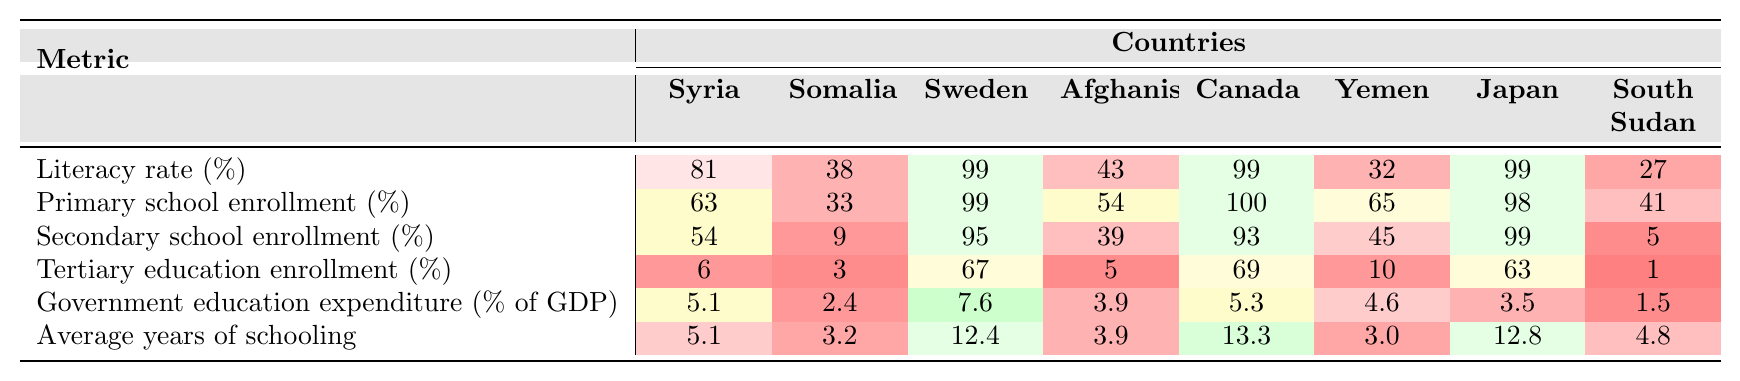What is the literacy rate in Syria? The table shows that the literacy rate in Syria is listed under the Literacy rate row and Syria column, which indicates a value of 81%
Answer: 81% What is the average years of schooling in Japan? The average years of schooling in Japan can be found under the Average years of schooling row and Japan column, showing a value of 12.8
Answer: 12.8 Which country has the highest primary school enrollment percentage? Looking at the Primary school enrollment row, Canada has the highest percentage at 100%, compared to the other listed countries
Answer: Canada Is the secondary school enrollment higher in Sweden or Canada? In the Secondary school enrollment row, Sweden has a value of 95, while Canada has a value of 93. Therefore, Sweden has the higher enrollment
Answer: Sweden What is the difference in tertiary education enrollment between Yemen and Somalia? Yemen's tertiary education enrollment is 10%, and Somalia's is 3%. The difference is 10 - 3 = 7%
Answer: 7% Which country has the lowest governmental education expenditure as a percentage of GDP? The Government education expenditure row indicates South Sudan has the lowest value at 1.5%
Answer: South Sudan Is the primary school enrollment in South Sudan higher than that of Afghanistan? The primary school enrollment in South Sudan is 41%, while Afghanistan's is 54%. Since 41% is less than 54%, the statement is false
Answer: No What is the average literacy rate of conflict-affected countries (Syria, Somalia, Afghanistan, Yemen, South Sudan)? Calculating the average involves summing the literacy rates: (81 + 63 + 6 + 32 + 27) = 209. Then, divide by 5, which gives 209/5 = 41.8
Answer: 41.8 Which country has a literacy rate higher than 90%? Reviewing the Literacy rate row, Sweden, Canada, and Japan all have literacy rates at or above 99%, meaning they fit this criterion
Answer: Sweden, Canada, Japan How does the literacy rate in Afghanistan compare to the average for conflict-affected countries? Afghanistan's literacy rate is 6%. The average for conflict-affected countries is 41.8%. Since 6% is lower than 41.8%, Afghanistan's rate is lower
Answer: Lower 